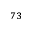Convert formula to latex. <formula><loc_0><loc_0><loc_500><loc_500>^ { 7 3 }</formula> 